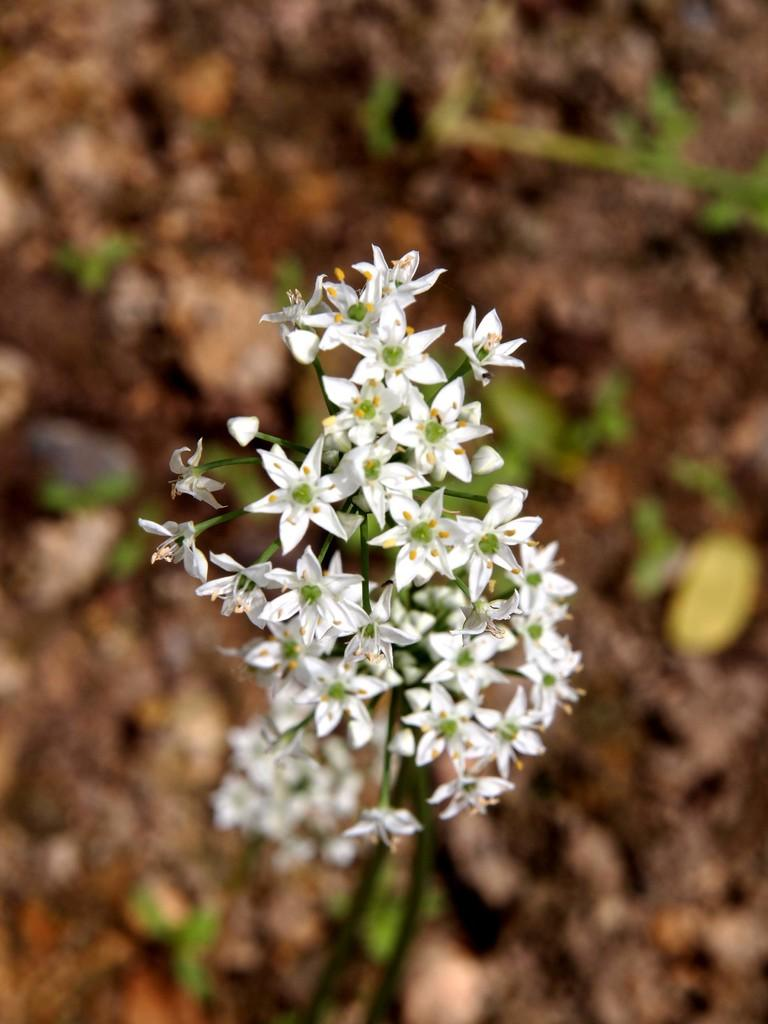What type of flowers are present in the image? There are many white flowers in the image. Where are the flowers located? The flowers are on a plant or grass. Is there any other color of flower visible in the image? There might be a yellow flower on the right side of the image. How many family members are driving in the image? There is no reference to family members or driving in the image; it features white flowers on a plant or grass. 